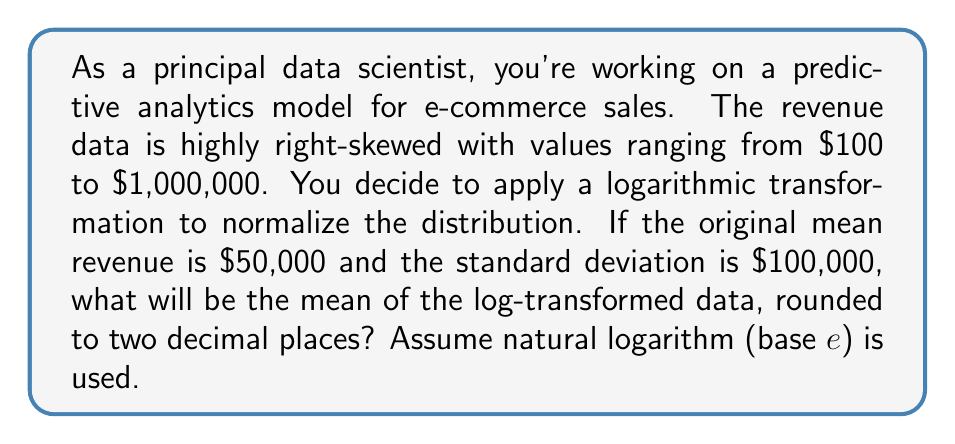Teach me how to tackle this problem. To solve this problem, we'll follow these steps:

1) The log-transformation we're using is the natural logarithm (ln). This transformation is often used to normalize right-skewed data.

2) For log-normal distributions, the relationship between the arithmetic mean ($\mu$) and standard deviation ($\sigma$) of the original data and the mean of the log-transformed data ($\mu_{\ln}$) is given by:

   $$\mu_{\ln} = \ln(\frac{\mu}{\sqrt{1 + (\frac{\sigma}{\mu})^2}})$$

3) We're given:
   $\mu = 50,000$ (original mean)
   $\sigma = 100,000$ (original standard deviation)

4) Let's substitute these values into the formula:

   $$\mu_{\ln} = \ln(\frac{50,000}{\sqrt{1 + (\frac{100,000}{50,000})^2}})$$

5) Simplify inside the parentheses:

   $$\mu_{\ln} = \ln(\frac{50,000}{\sqrt{1 + 4}})$$

6) Simplify further:

   $$\mu_{\ln} = \ln(\frac{50,000}{\sqrt{5}})$$

7) Calculate:

   $$\mu_{\ln} = \ln(22,360.68) \approx 10.0149$$

8) Rounding to two decimal places:

   $$\mu_{\ln} \approx 10.01$$
Answer: 10.01 